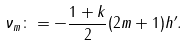Convert formula to latex. <formula><loc_0><loc_0><loc_500><loc_500>\nu _ { m } \colon = - \frac { 1 + k } { 2 } ( 2 m + 1 ) h ^ { \prime } .</formula> 